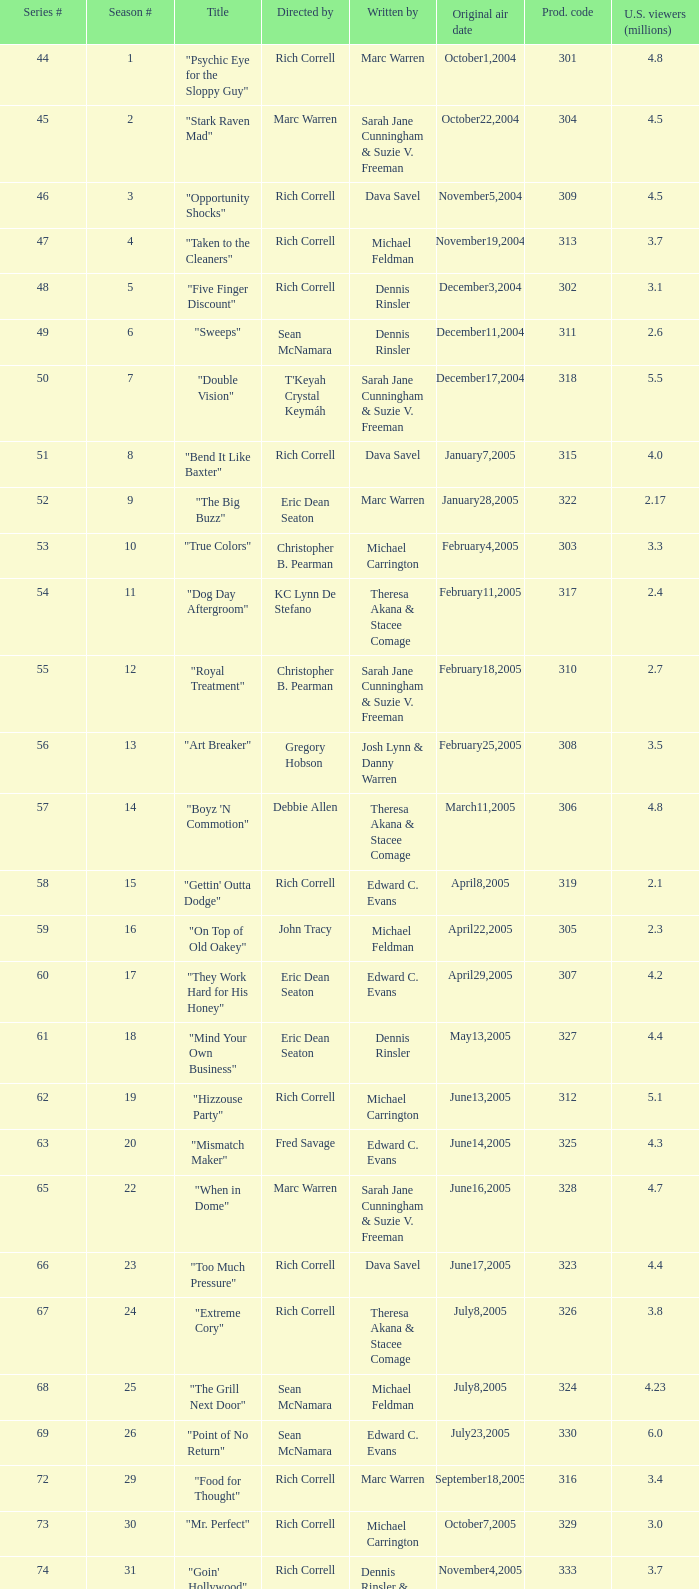In which episode of the season did the title "vision impossible" appear? 34.0. 